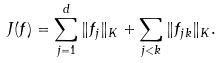Convert formula to latex. <formula><loc_0><loc_0><loc_500><loc_500>J ( f ) = \sum _ { j = 1 } ^ { d } \| f _ { j } \| _ { K } + \sum _ { j < k } \| f _ { j k } \| _ { K } .</formula> 